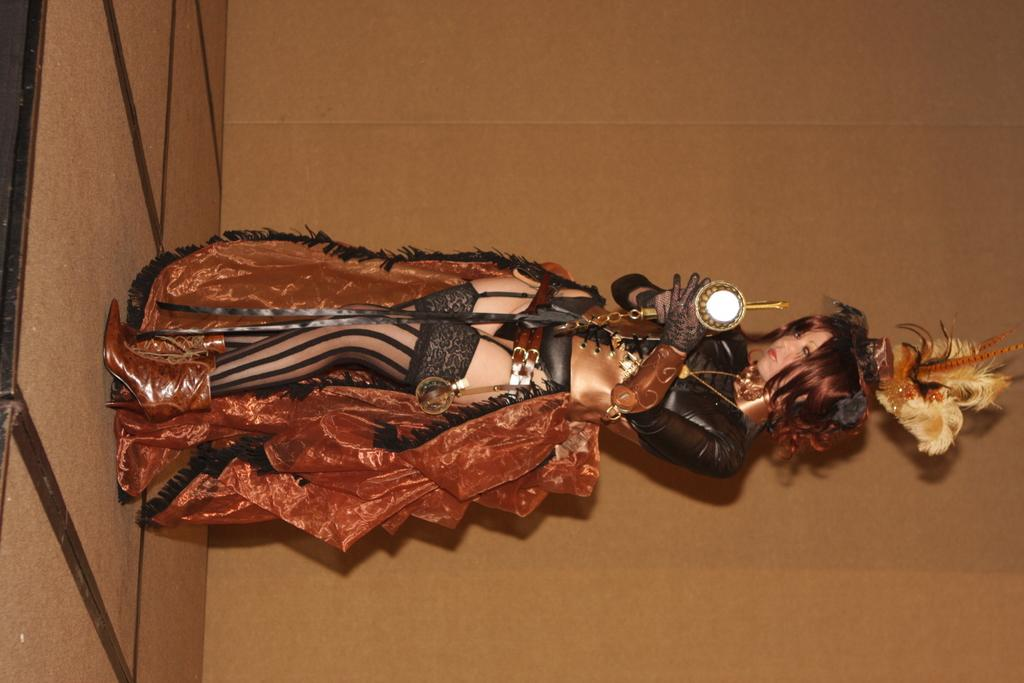What is the main subject of the image? There is a woman standing in the middle of the image. What is the woman holding in the image? The woman is holding an object. What can be seen in the background of the image? There is a wall in the background of the image. What is visible on the left side of the image? There is a floor on the left side of the image. What toys can be seen on the floor in the image? There are no toys visible on the floor in the image. 